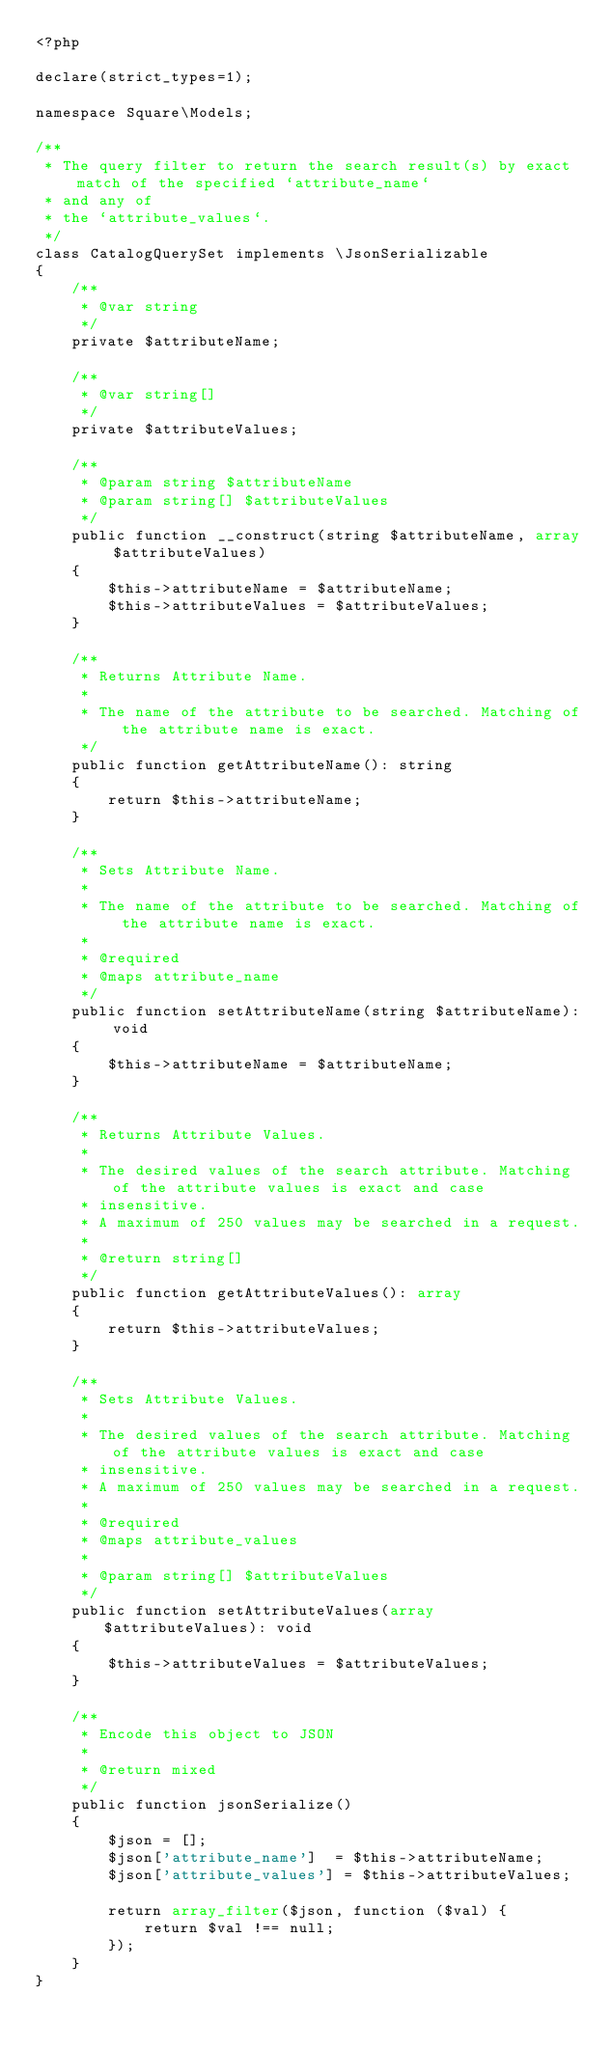<code> <loc_0><loc_0><loc_500><loc_500><_PHP_><?php

declare(strict_types=1);

namespace Square\Models;

/**
 * The query filter to return the search result(s) by exact match of the specified `attribute_name`
 * and any of
 * the `attribute_values`.
 */
class CatalogQuerySet implements \JsonSerializable
{
    /**
     * @var string
     */
    private $attributeName;

    /**
     * @var string[]
     */
    private $attributeValues;

    /**
     * @param string $attributeName
     * @param string[] $attributeValues
     */
    public function __construct(string $attributeName, array $attributeValues)
    {
        $this->attributeName = $attributeName;
        $this->attributeValues = $attributeValues;
    }

    /**
     * Returns Attribute Name.
     *
     * The name of the attribute to be searched. Matching of the attribute name is exact.
     */
    public function getAttributeName(): string
    {
        return $this->attributeName;
    }

    /**
     * Sets Attribute Name.
     *
     * The name of the attribute to be searched. Matching of the attribute name is exact.
     *
     * @required
     * @maps attribute_name
     */
    public function setAttributeName(string $attributeName): void
    {
        $this->attributeName = $attributeName;
    }

    /**
     * Returns Attribute Values.
     *
     * The desired values of the search attribute. Matching of the attribute values is exact and case
     * insensitive.
     * A maximum of 250 values may be searched in a request.
     *
     * @return string[]
     */
    public function getAttributeValues(): array
    {
        return $this->attributeValues;
    }

    /**
     * Sets Attribute Values.
     *
     * The desired values of the search attribute. Matching of the attribute values is exact and case
     * insensitive.
     * A maximum of 250 values may be searched in a request.
     *
     * @required
     * @maps attribute_values
     *
     * @param string[] $attributeValues
     */
    public function setAttributeValues(array $attributeValues): void
    {
        $this->attributeValues = $attributeValues;
    }

    /**
     * Encode this object to JSON
     *
     * @return mixed
     */
    public function jsonSerialize()
    {
        $json = [];
        $json['attribute_name']  = $this->attributeName;
        $json['attribute_values'] = $this->attributeValues;

        return array_filter($json, function ($val) {
            return $val !== null;
        });
    }
}
</code> 